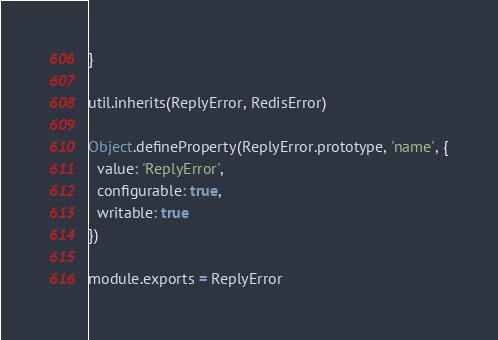Convert code to text. <code><loc_0><loc_0><loc_500><loc_500><_JavaScript_>}

util.inherits(ReplyError, RedisError)

Object.defineProperty(ReplyError.prototype, 'name', {
  value: 'ReplyError',
  configurable: true,
  writable: true
})

module.exports = ReplyError
</code> 